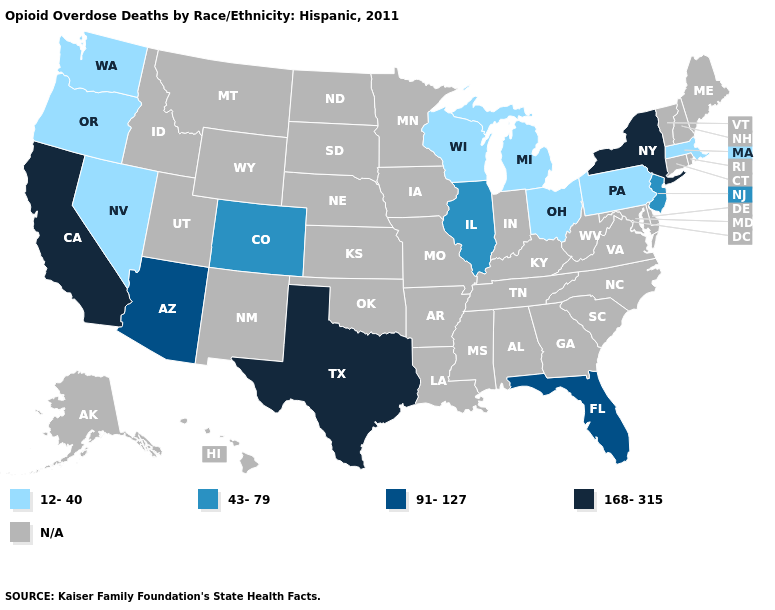Which states hav the highest value in the West?
Keep it brief. California. What is the value of Wisconsin?
Concise answer only. 12-40. Which states have the highest value in the USA?
Quick response, please. California, New York, Texas. Name the states that have a value in the range 12-40?
Be succinct. Massachusetts, Michigan, Nevada, Ohio, Oregon, Pennsylvania, Washington, Wisconsin. Does Oregon have the lowest value in the West?
Concise answer only. Yes. Name the states that have a value in the range 91-127?
Be succinct. Arizona, Florida. Name the states that have a value in the range 168-315?
Keep it brief. California, New York, Texas. What is the highest value in states that border Oklahoma?
Quick response, please. 168-315. What is the value of Alaska?
Give a very brief answer. N/A. What is the lowest value in the USA?
Be succinct. 12-40. Does Texas have the lowest value in the South?
Write a very short answer. No. Which states have the lowest value in the South?
Answer briefly. Florida. What is the value of Texas?
Quick response, please. 168-315. Name the states that have a value in the range 12-40?
Short answer required. Massachusetts, Michigan, Nevada, Ohio, Oregon, Pennsylvania, Washington, Wisconsin. 